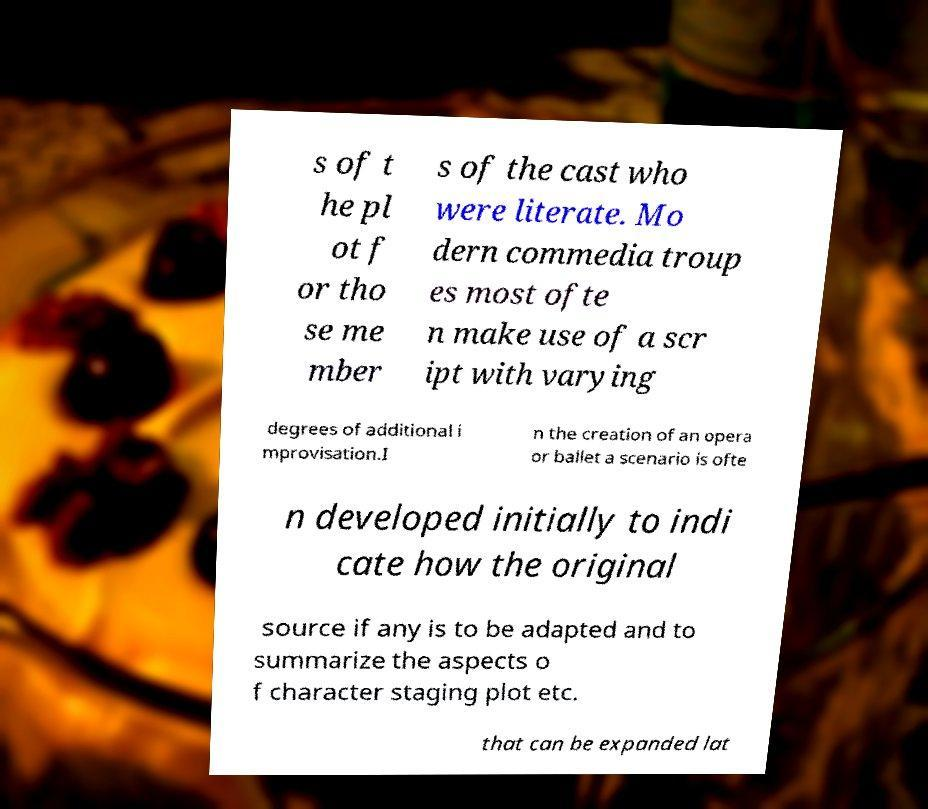Can you read and provide the text displayed in the image?This photo seems to have some interesting text. Can you extract and type it out for me? s of t he pl ot f or tho se me mber s of the cast who were literate. Mo dern commedia troup es most ofte n make use of a scr ipt with varying degrees of additional i mprovisation.I n the creation of an opera or ballet a scenario is ofte n developed initially to indi cate how the original source if any is to be adapted and to summarize the aspects o f character staging plot etc. that can be expanded lat 